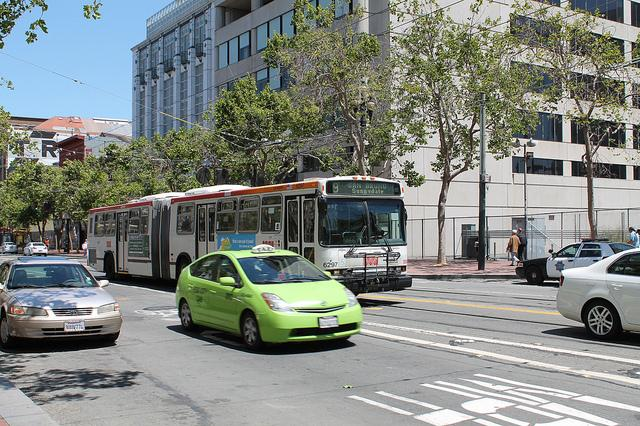Why is one car such a bright unusual color? Please explain your reasoning. taxi. It is brightly colored so that it can easily be spotted. 